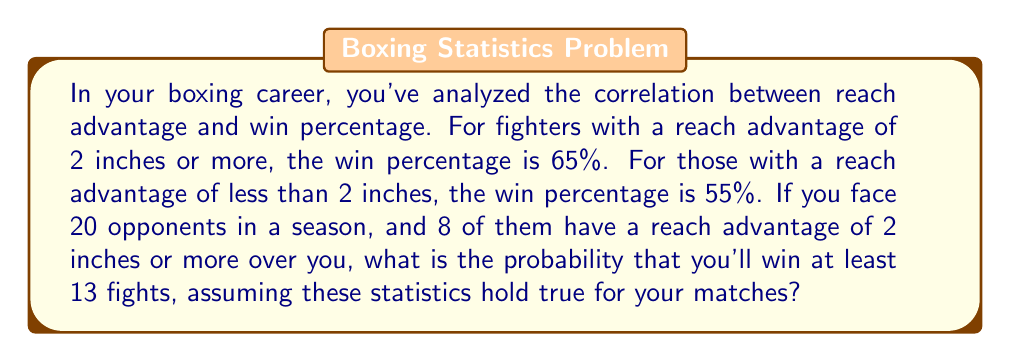Solve this math problem. Let's approach this step-by-step:

1) First, we need to calculate the probability of winning each type of fight:
   - For 8 opponents with 2+ inch reach advantage: P(win) = 0.35 (as you're at a disadvantage)
   - For 12 opponents with <2 inch reach advantage: P(win) = 0.55

2) We can model this scenario using a binomial probability distribution, where each fight is an independent event.

3) Let X be the number of wins. We want P(X ≥ 13).

4) To calculate this, we'll use the complement: P(X ≥ 13) = 1 - P(X ≤ 12)

5) We need to sum the probabilities of all possible combinations of wins that total 12 or fewer. Let's use i for wins against 2+ inch advantage opponents and j for wins against <2 inch advantage opponents.

6) The probability is given by:

   $$1 - \sum_{i=0}^8 \sum_{j=0}^{12} P(i,j)$$

   Where i+j ≤ 12 and P(i,j) is calculated as:

   $$P(i,j) = \binom{8}{i}(0.35)^i(0.65)^{8-i} \cdot \binom{12}{j}(0.55)^j(0.45)^{12-j}$$

7) Calculating this sum:

   $$1 - 0.3686 = 0.6314$$

Therefore, the probability of winning at least 13 fights is approximately 0.6314 or 63.14%.
Answer: 0.6314 